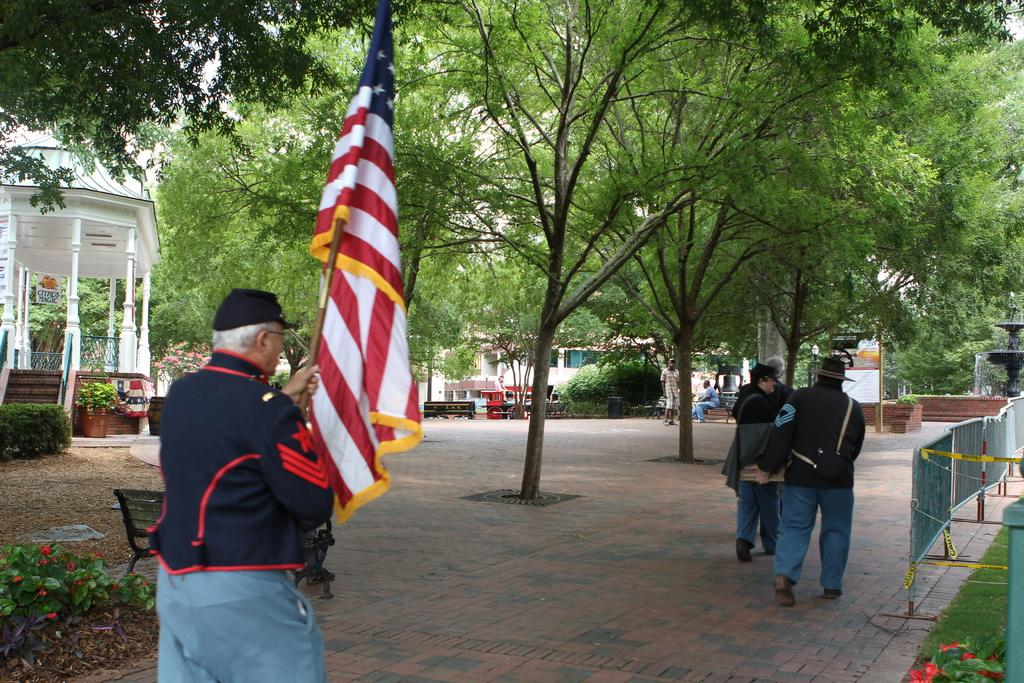What is the person in the image holding? The person is holding a flag with a stick. What is the person doing with the flag? The person is walking while holding the flag. What type of vegetation can be seen in the image? Plants, grass, and trees are visible in the image. Can you describe the background of the image? There are other persons in the background and a board with poles. What type of oatmeal can be seen in the image? There is no oatmeal present in the image. Can you describe the behavior of the goose in the image? There is no goose present in the image. 